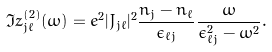Convert formula to latex. <formula><loc_0><loc_0><loc_500><loc_500>\Im z _ { j \ell } ^ { ( 2 ) } ( \omega ) = e ^ { 2 } | J _ { j \ell } | ^ { 2 } \frac { n _ { j } - n _ { \ell } } { \epsilon _ { \ell j } } \frac { \omega } { \epsilon _ { \ell j } ^ { 2 } - \omega ^ { 2 } } .</formula> 